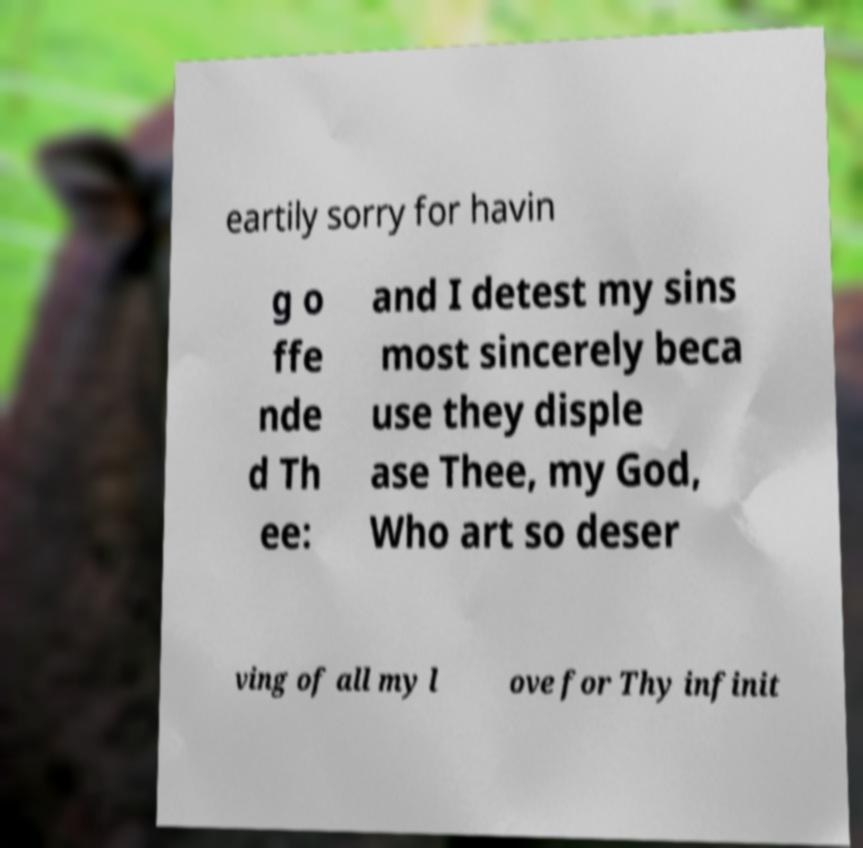Please read and relay the text visible in this image. What does it say? eartily sorry for havin g o ffe nde d Th ee: and I detest my sins most sincerely beca use they disple ase Thee, my God, Who art so deser ving of all my l ove for Thy infinit 